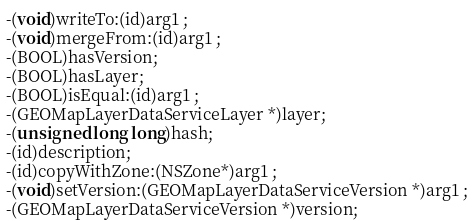<code> <loc_0><loc_0><loc_500><loc_500><_C_>-(void)writeTo:(id)arg1 ;
-(void)mergeFrom:(id)arg1 ;
-(BOOL)hasVersion;
-(BOOL)hasLayer;
-(BOOL)isEqual:(id)arg1 ;
-(GEOMapLayerDataServiceLayer *)layer;
-(unsigned long long)hash;
-(id)description;
-(id)copyWithZone:(NSZone*)arg1 ;
-(void)setVersion:(GEOMapLayerDataServiceVersion *)arg1 ;
-(GEOMapLayerDataServiceVersion *)version;</code> 